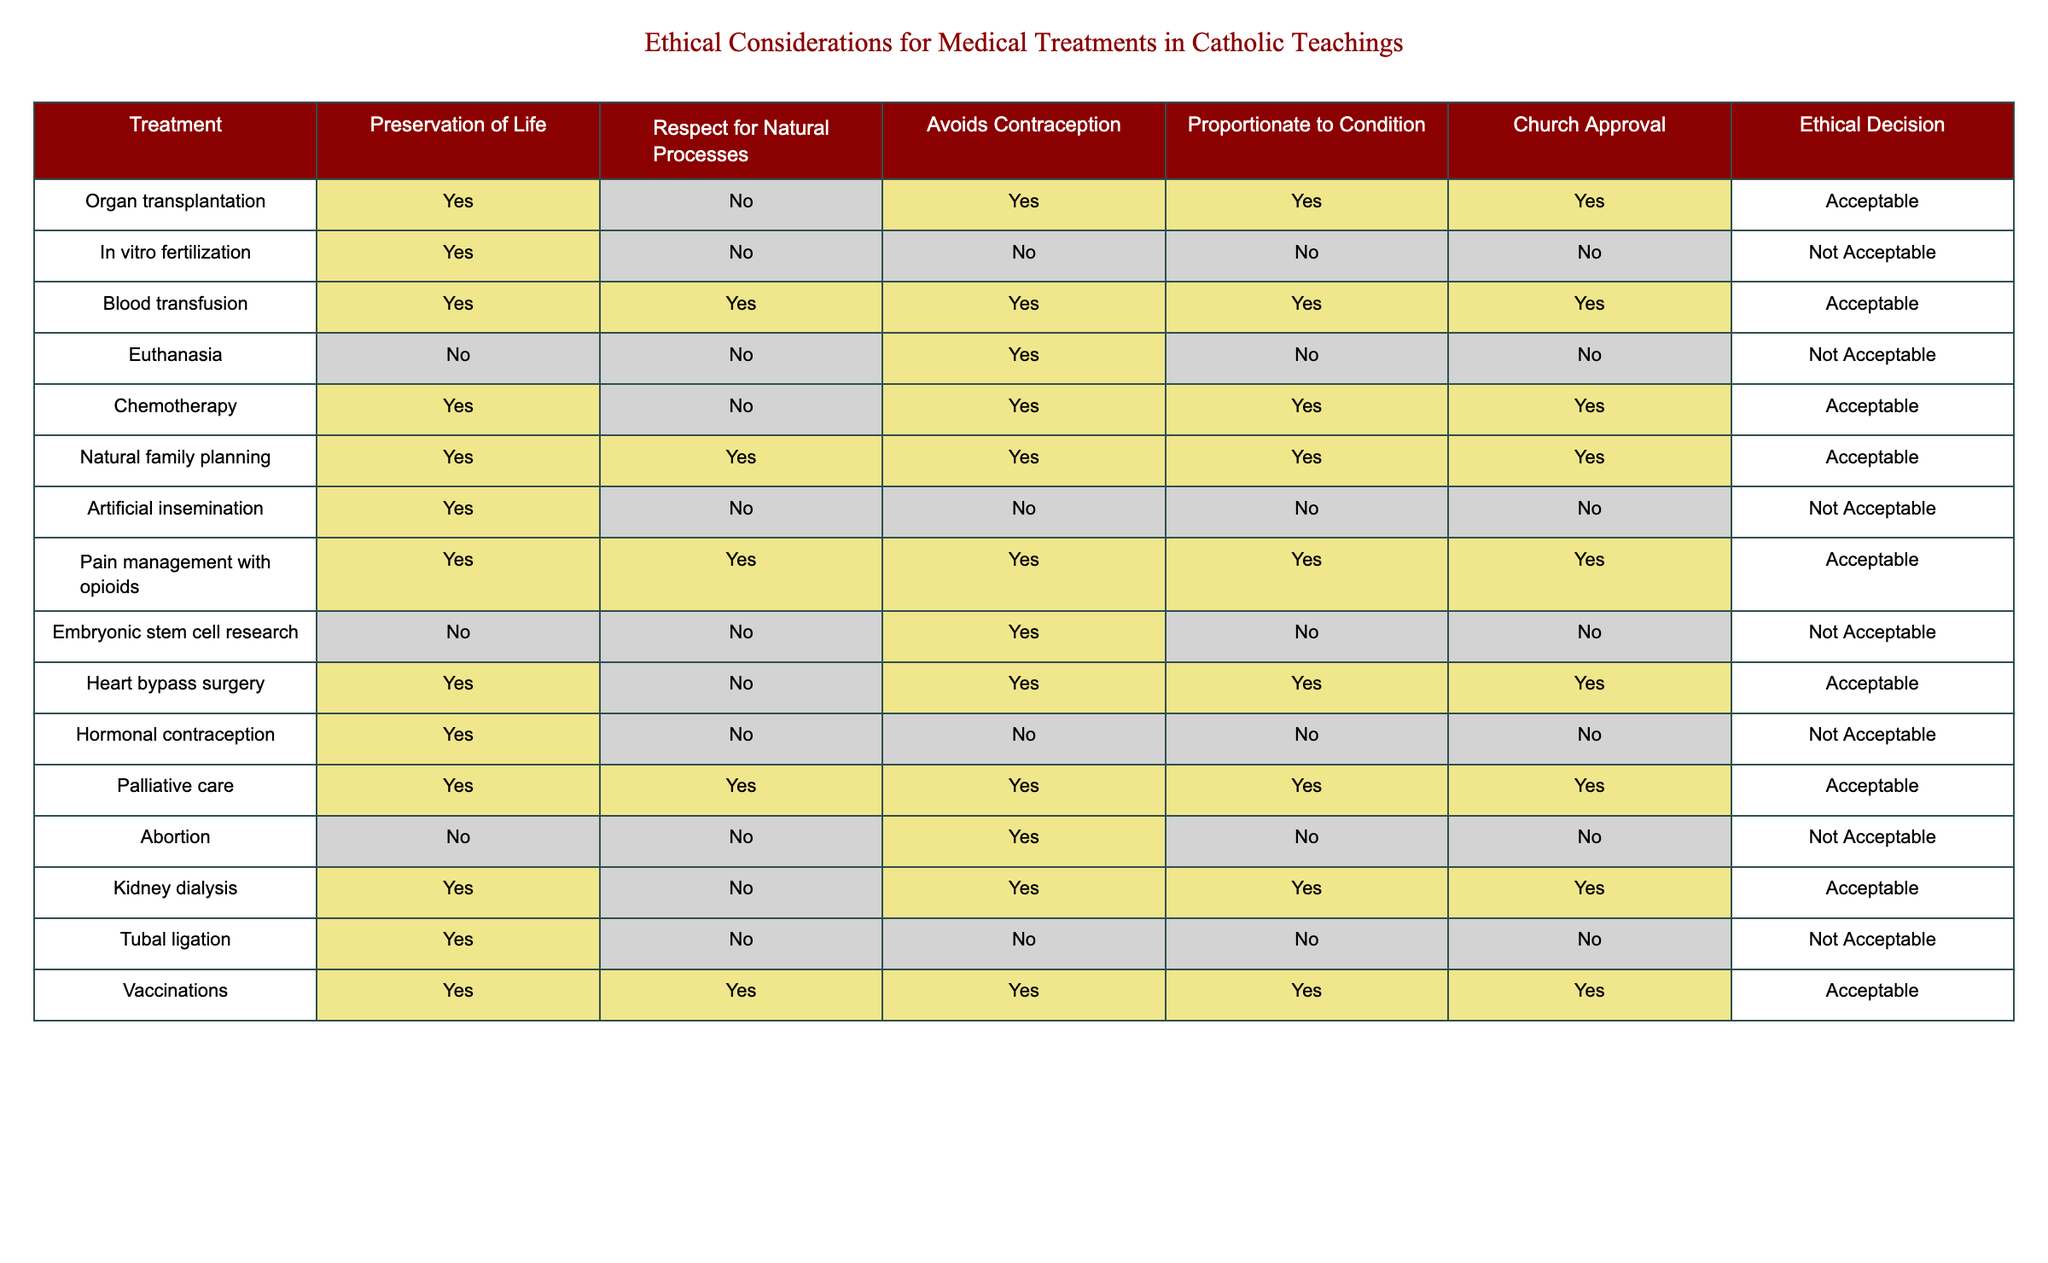What treatments are considered acceptable according to the table? In the table, the treatments considered acceptable are listed under the "Ethical Decision" column where the value is "Acceptable." These treatments include: Organ transplantation, Blood transfusion, Chemotherapy, Natural family planning, Pain management with opioids, Heart bypass surgery, Palliative care, Kidney dialysis, and Vaccinations.
Answer: Organ transplantation, Blood transfusion, Chemotherapy, Natural family planning, Pain management with opioids, Heart bypass surgery, Palliative care, Kidney dialysis, Vaccinations Are there any treatments that preserve life but are not endorsed by the Church? To answer this, we look for treatments with "Yes" in the Preservation of Life column and "No" in the Church Approval column. In the table, Euthanasia, Embryonic stem cell research, and Abortion preserve life but are not endorsed by the Church.
Answer: Yes, Euthanasia, Embryonic stem cell research, Abortion How many treatments avoid contraception? We check the "Avoids Contraception" column for treatments with "Yes." The treatments that avoid contraception are: Organ transplantation, Blood transfusion, Chemotherapy, Natural family planning, Pain management with opioids, Heart bypass surgery, Palliative care, Kidney dialysis, and Vaccinations. Counting these gives us 9 treatments.
Answer: 9 Which treatment has both Church approval and respects natural processes? We look at the table and identify treatments that have "Yes" for both "Church Approval" and "Respect for Natural Processes." The treatments meeting this criteria are: Blood transfusion, Natural family planning, Pain management with opioids, Palliative care, and Vaccinations.
Answer: Blood transfusion, Natural family planning, Pain management with opioids, Palliative care, Vaccinations Is it true that all treatments that are acceptable also respect natural processes? We need to compare the rows of acceptable treatments and see if any have "No" for "Respect for Natural Processes." From the acceptable treatments, Heart bypass surgery and Chemotherapy show "No" for this column. Thus, it is false.
Answer: No 